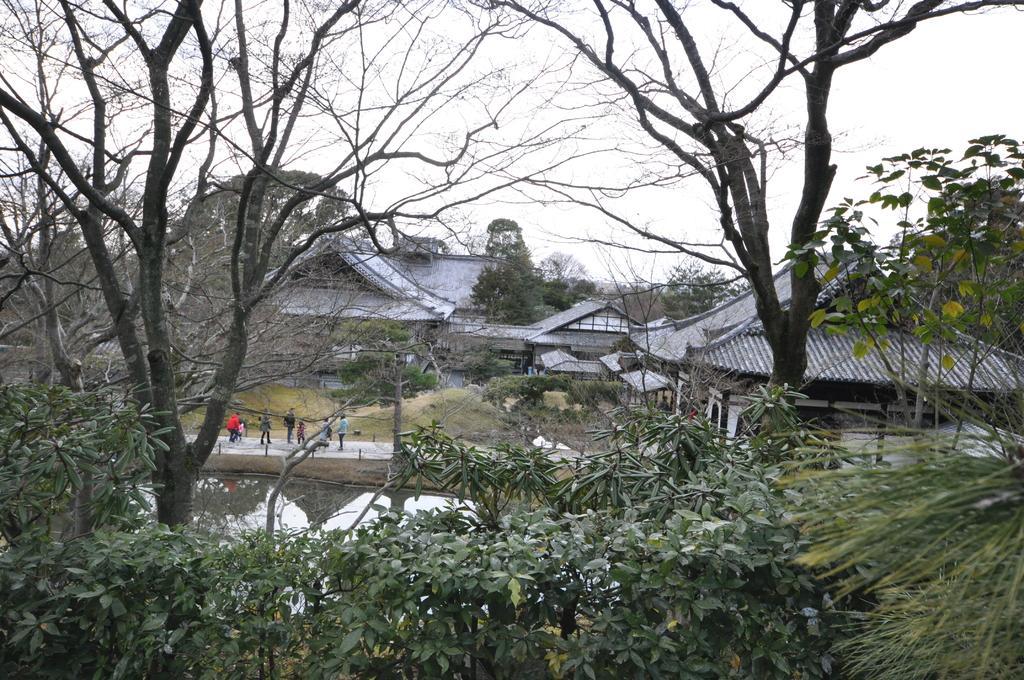Could you give a brief overview of what you see in this image? In this image I can see number of trees, buildings, water and over there I can see few people are standing. 